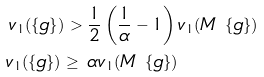<formula> <loc_0><loc_0><loc_500><loc_500>v _ { 1 } ( \{ g \} ) > & \ \frac { 1 } { 2 } \left ( \frac { 1 } { \alpha } - 1 \right ) v _ { 1 } ( M \ \{ g \} ) \\ v _ { 1 } ( \{ g \} ) \geq & \ \alpha v _ { 1 } ( M \ \{ g \} )</formula> 